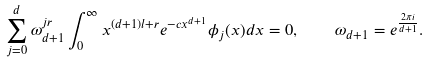<formula> <loc_0><loc_0><loc_500><loc_500>\sum _ { j = 0 } ^ { d } \omega _ { d + 1 } ^ { j r } \int _ { 0 } ^ { \infty } x ^ { ( d + 1 ) l + r } e ^ { - c x ^ { d + 1 } } \phi _ { j } ( x ) d x = 0 , \quad \omega _ { d + 1 } = e ^ { \frac { 2 \pi i } { d + 1 } } .</formula> 